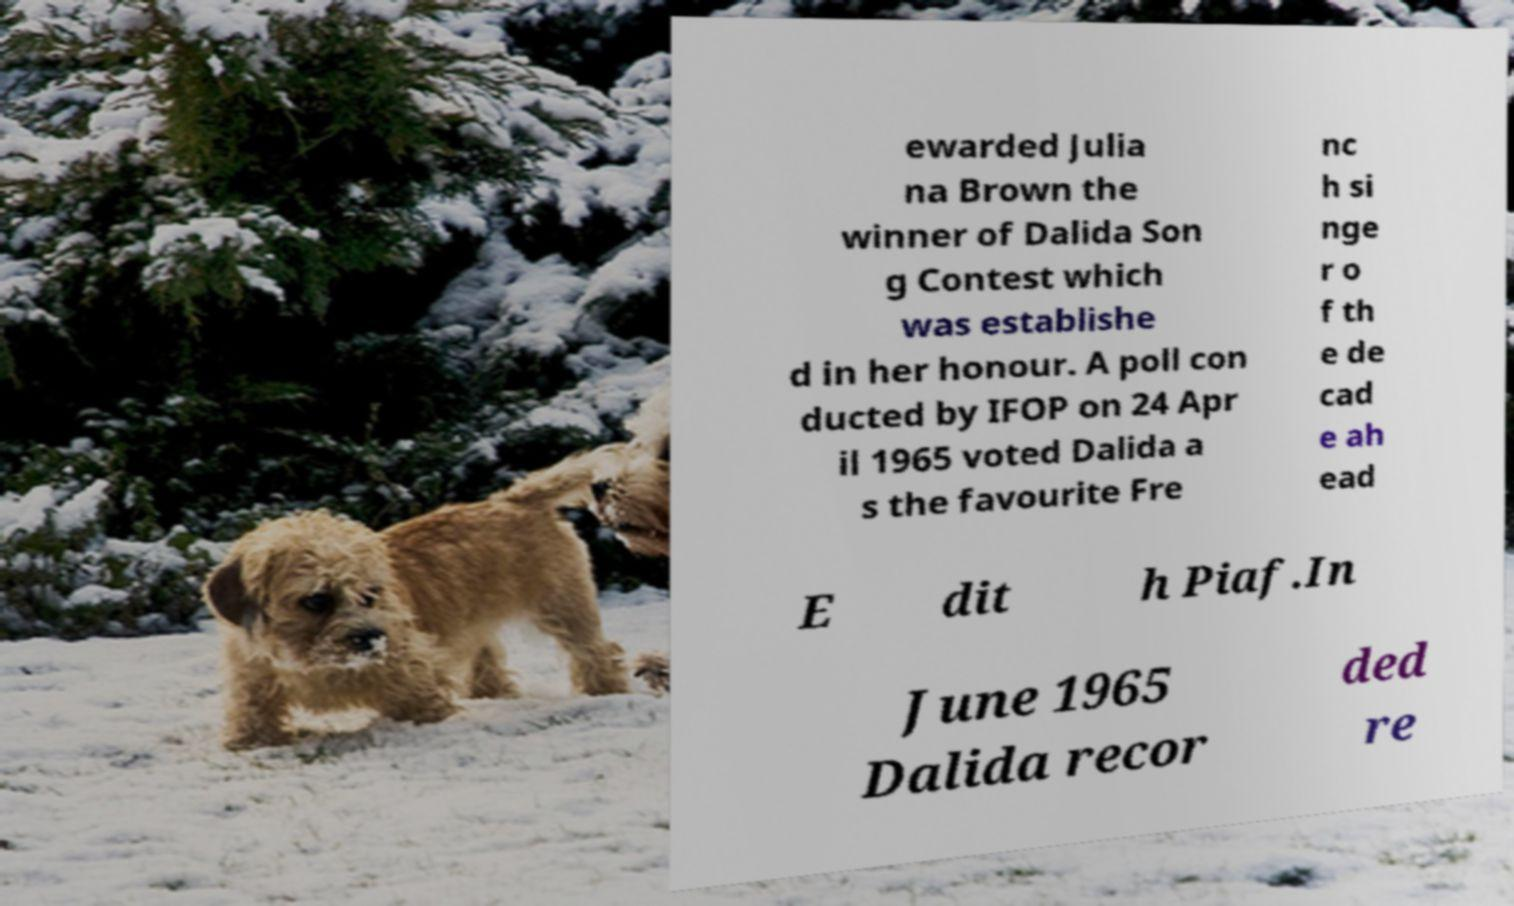I need the written content from this picture converted into text. Can you do that? ewarded Julia na Brown the winner of Dalida Son g Contest which was establishe d in her honour. A poll con ducted by IFOP on 24 Apr il 1965 voted Dalida a s the favourite Fre nc h si nge r o f th e de cad e ah ead E dit h Piaf.In June 1965 Dalida recor ded re 